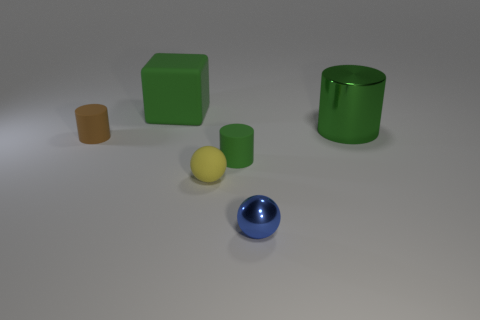There is a metal object to the left of the green metal thing; is its shape the same as the big object that is on the right side of the small blue shiny ball? No, the shapes are different. To the left of the green cylinder is a small yellow cylinder, while the big object to the right of the blue sphere is a green cube. Despite similar colors for the cylinder and the cube, their shapes are distinct—one is cylindrical and the other is cubical. 